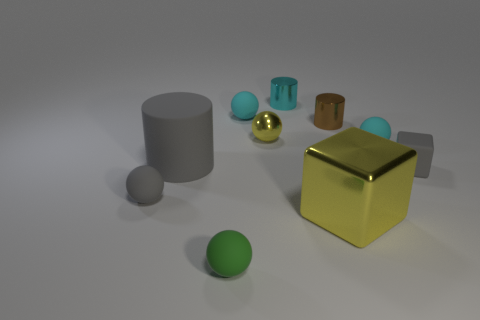Do the small yellow thing and the gray ball have the same material?
Make the answer very short. No. Is the number of gray things right of the big metallic thing greater than the number of red shiny cylinders?
Provide a short and direct response. Yes. Do the large rubber object and the small block have the same color?
Your answer should be very brief. Yes. How many large green metallic things are the same shape as the small brown metallic object?
Offer a terse response. 0. The brown thing that is the same material as the large yellow cube is what size?
Your answer should be very brief. Small. There is a object that is both to the left of the matte block and to the right of the tiny brown object; what is its color?
Your response must be concise. Cyan. What number of yellow metal cubes have the same size as the green sphere?
Keep it short and to the point. 0. There is a ball that is the same color as the big rubber object; what size is it?
Provide a succinct answer. Small. How big is the metallic object that is both in front of the tiny brown metallic cylinder and right of the tiny yellow shiny thing?
Your response must be concise. Large. There is a big thing left of the shiny thing behind the brown thing; how many tiny cyan rubber balls are in front of it?
Your response must be concise. 0. 